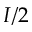<formula> <loc_0><loc_0><loc_500><loc_500>I / 2</formula> 